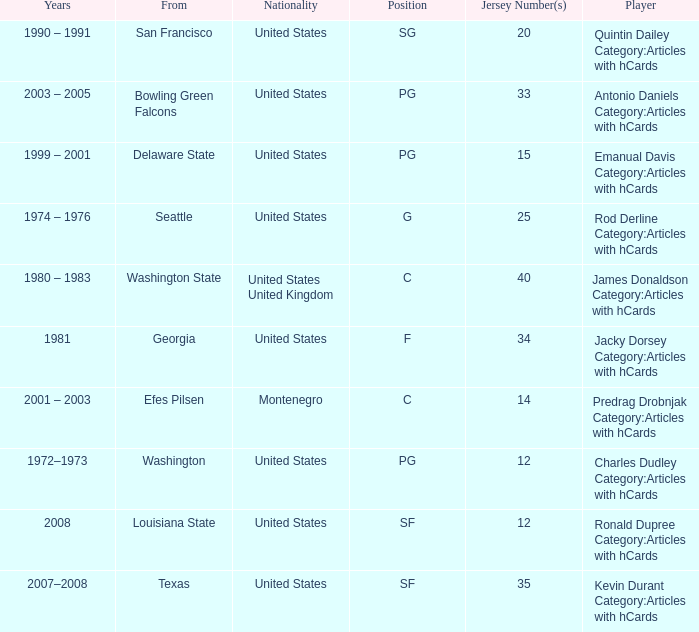What college was the player with the jersey number of 34 from? Georgia. 